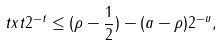<formula> <loc_0><loc_0><loc_500><loc_500>\ t x t 2 ^ { - t } \leq ( \rho - \frac { 1 } { 2 } ) - ( a - \rho ) 2 ^ { - u } ,</formula> 